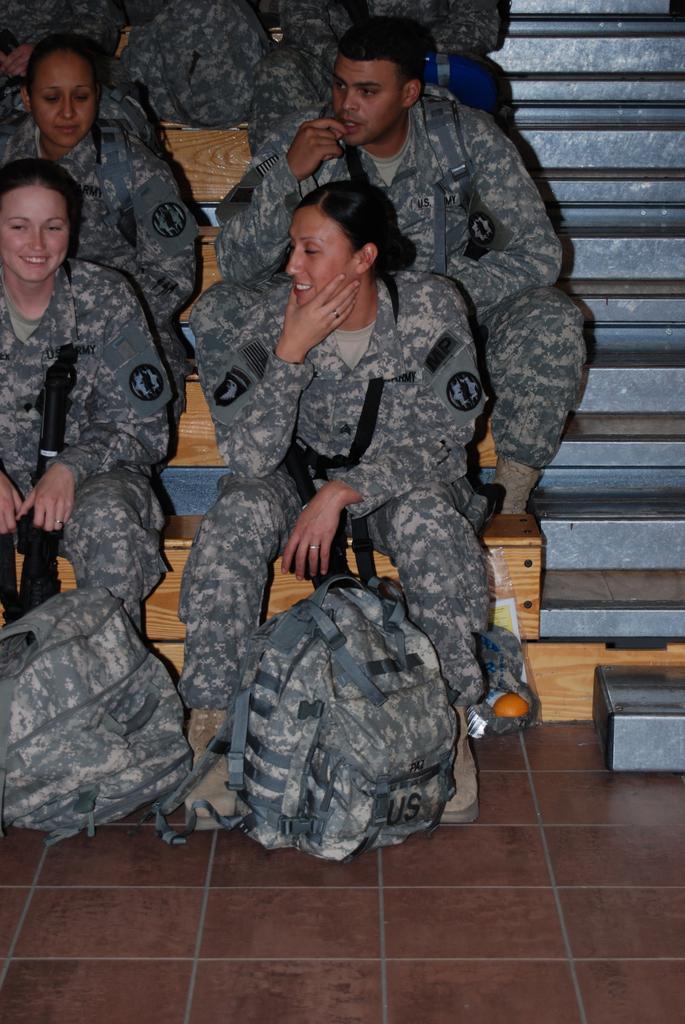Can you describe this image briefly? In the image we can see few persons were sitting on the steps. And in the front two persons were smiling. In the bottom we can see two backpacks. 